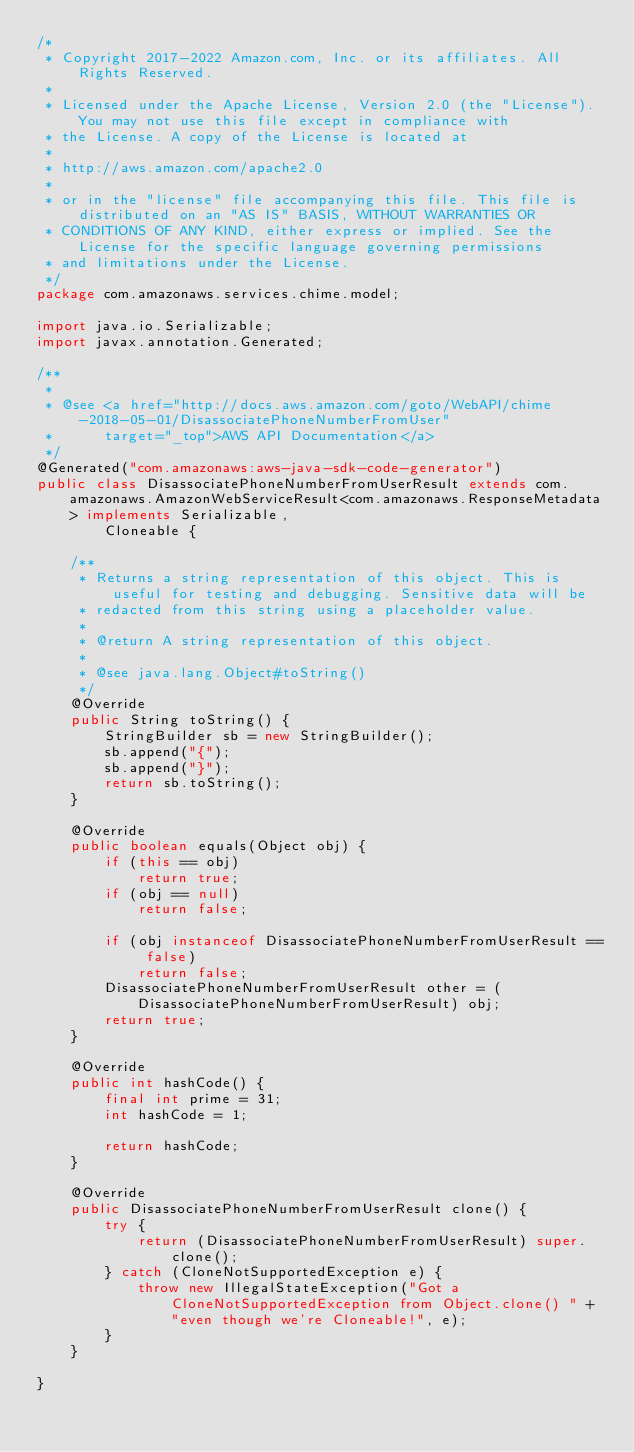<code> <loc_0><loc_0><loc_500><loc_500><_Java_>/*
 * Copyright 2017-2022 Amazon.com, Inc. or its affiliates. All Rights Reserved.
 * 
 * Licensed under the Apache License, Version 2.0 (the "License"). You may not use this file except in compliance with
 * the License. A copy of the License is located at
 * 
 * http://aws.amazon.com/apache2.0
 * 
 * or in the "license" file accompanying this file. This file is distributed on an "AS IS" BASIS, WITHOUT WARRANTIES OR
 * CONDITIONS OF ANY KIND, either express or implied. See the License for the specific language governing permissions
 * and limitations under the License.
 */
package com.amazonaws.services.chime.model;

import java.io.Serializable;
import javax.annotation.Generated;

/**
 * 
 * @see <a href="http://docs.aws.amazon.com/goto/WebAPI/chime-2018-05-01/DisassociatePhoneNumberFromUser"
 *      target="_top">AWS API Documentation</a>
 */
@Generated("com.amazonaws:aws-java-sdk-code-generator")
public class DisassociatePhoneNumberFromUserResult extends com.amazonaws.AmazonWebServiceResult<com.amazonaws.ResponseMetadata> implements Serializable,
        Cloneable {

    /**
     * Returns a string representation of this object. This is useful for testing and debugging. Sensitive data will be
     * redacted from this string using a placeholder value.
     *
     * @return A string representation of this object.
     *
     * @see java.lang.Object#toString()
     */
    @Override
    public String toString() {
        StringBuilder sb = new StringBuilder();
        sb.append("{");
        sb.append("}");
        return sb.toString();
    }

    @Override
    public boolean equals(Object obj) {
        if (this == obj)
            return true;
        if (obj == null)
            return false;

        if (obj instanceof DisassociatePhoneNumberFromUserResult == false)
            return false;
        DisassociatePhoneNumberFromUserResult other = (DisassociatePhoneNumberFromUserResult) obj;
        return true;
    }

    @Override
    public int hashCode() {
        final int prime = 31;
        int hashCode = 1;

        return hashCode;
    }

    @Override
    public DisassociatePhoneNumberFromUserResult clone() {
        try {
            return (DisassociatePhoneNumberFromUserResult) super.clone();
        } catch (CloneNotSupportedException e) {
            throw new IllegalStateException("Got a CloneNotSupportedException from Object.clone() " + "even though we're Cloneable!", e);
        }
    }

}
</code> 